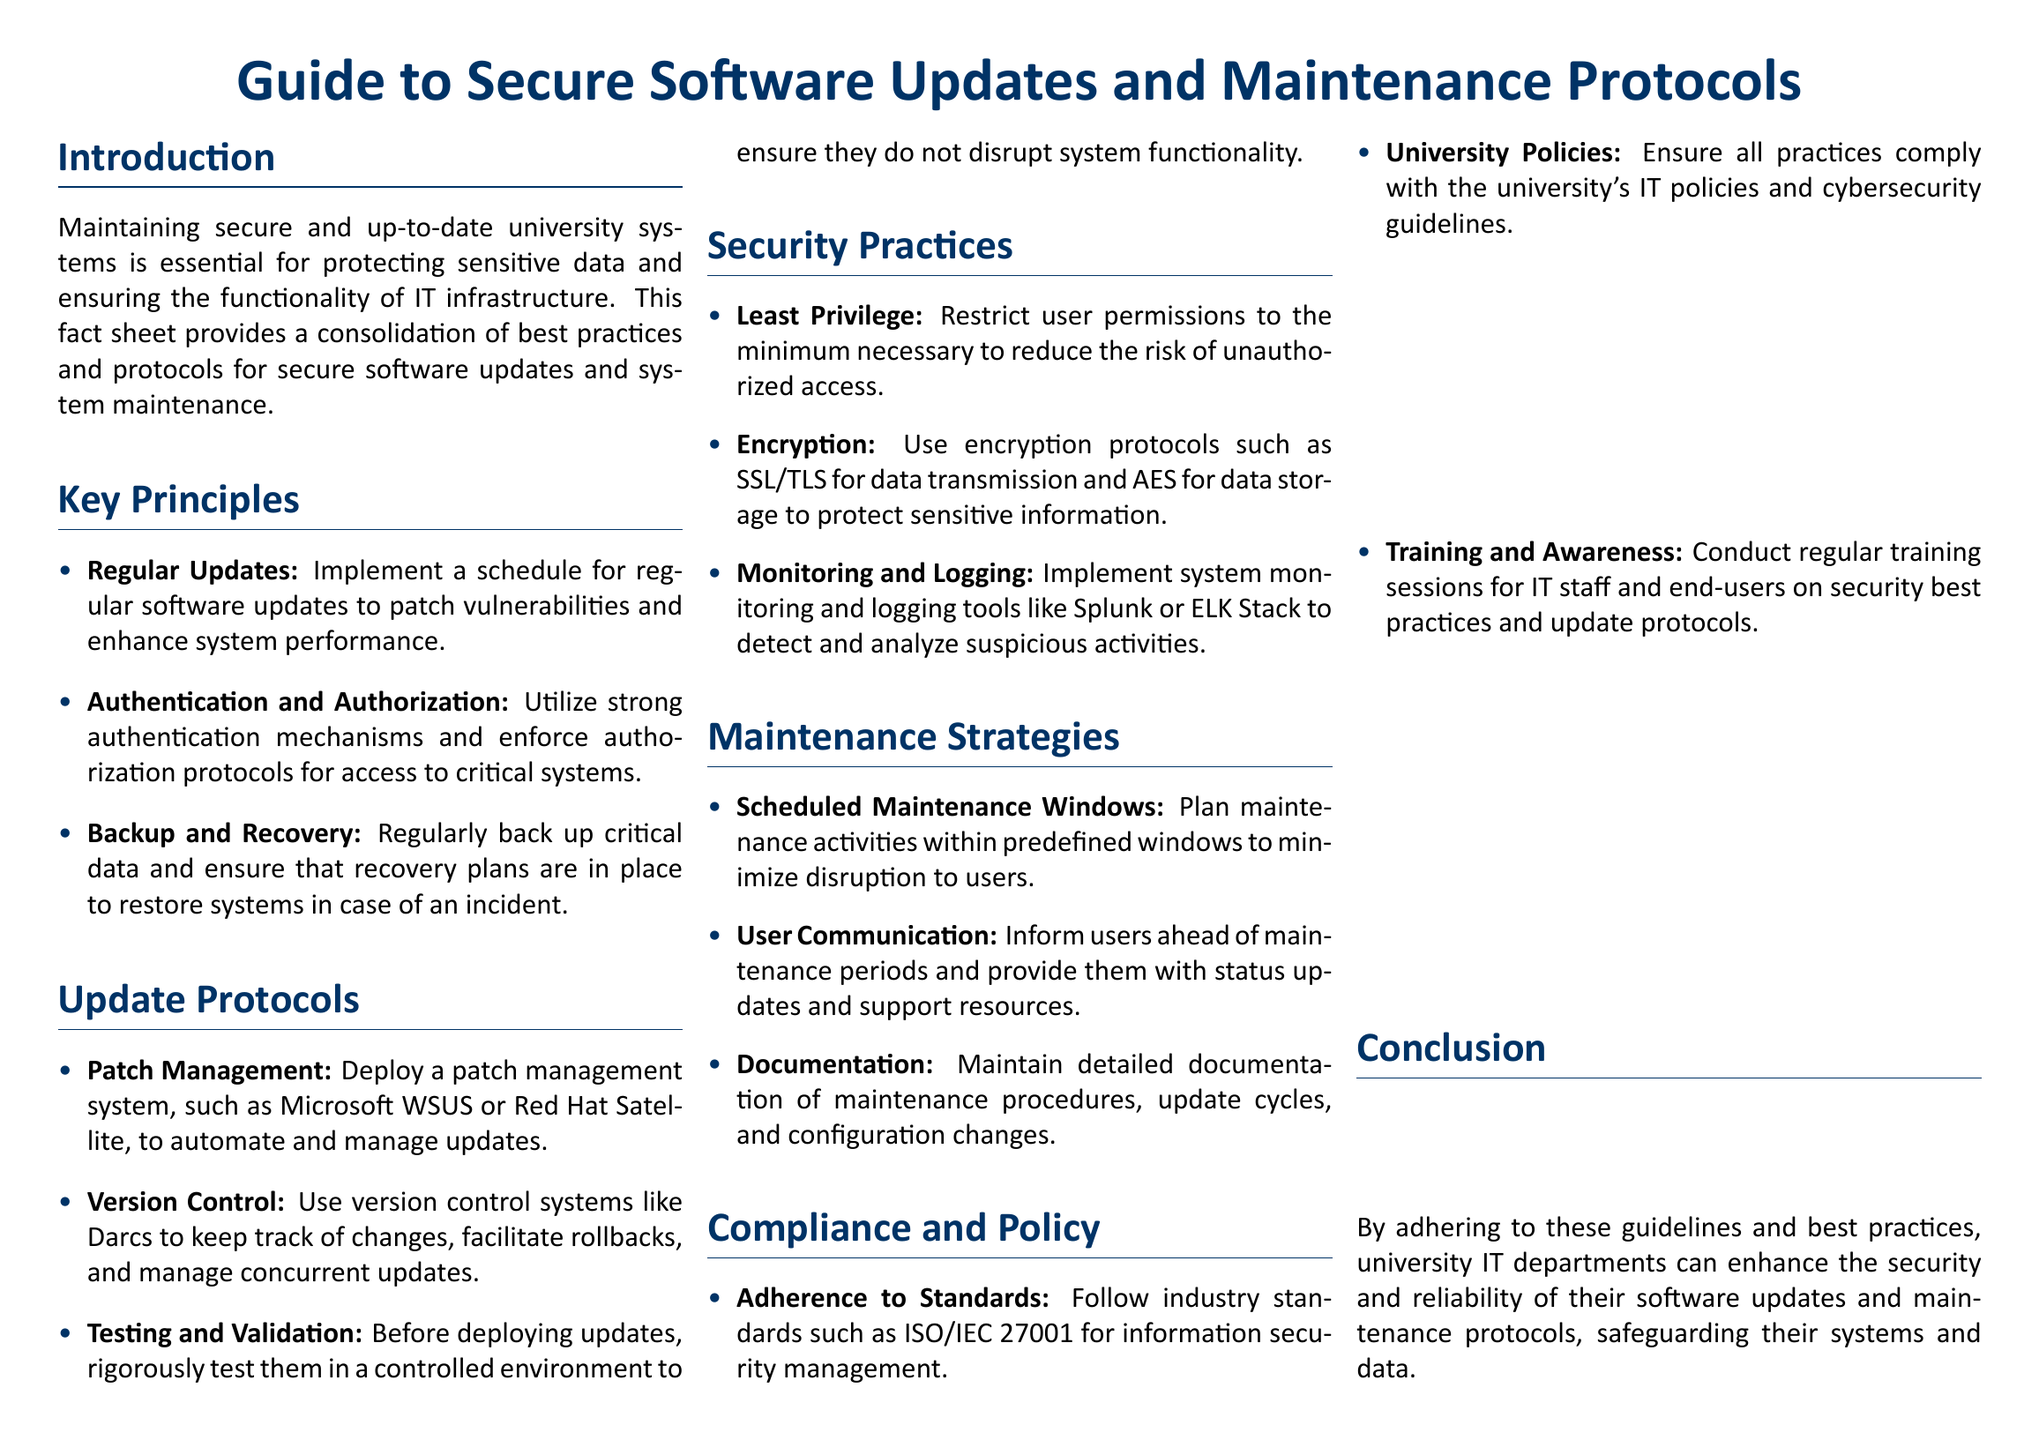what is the main focus of the fact sheet? The main focus is maintaining secure and up-to-date university systems for data protection and IT infrastructure functionality.
Answer: secure software updates and maintenance protocols what is one of the key principles mentioned? Key principles include various practices for maintaining system security, such as regular updates.
Answer: Regular Updates which system is recommended for patch management? The document mentions systems for managing updates, one of which is Microsoft WSUS.
Answer: Microsoft WSUS what should be implemented for monitoring and logging? The document suggests tools that help in tracking system activities, including Splunk.
Answer: Splunk what compliance standard is referenced? The text emphasizes the importance of adhering to various standards, specifically mentioning ISO/IEC 27001.
Answer: ISO/IEC 27001 what is advised for user permissions? The document outlines best practices for user access, including the principle of restricting permissions.
Answer: Least Privilege what is the recommended protocol for user communication during maintenance? The fact sheet advises keeping users informed about upcoming maintenance and providing updates.
Answer: User Communication which encryption protocol is suggested for data transmission? The document recommends certain security measures for data protection, specifically using SSL/TLS.
Answer: SSL/TLS 